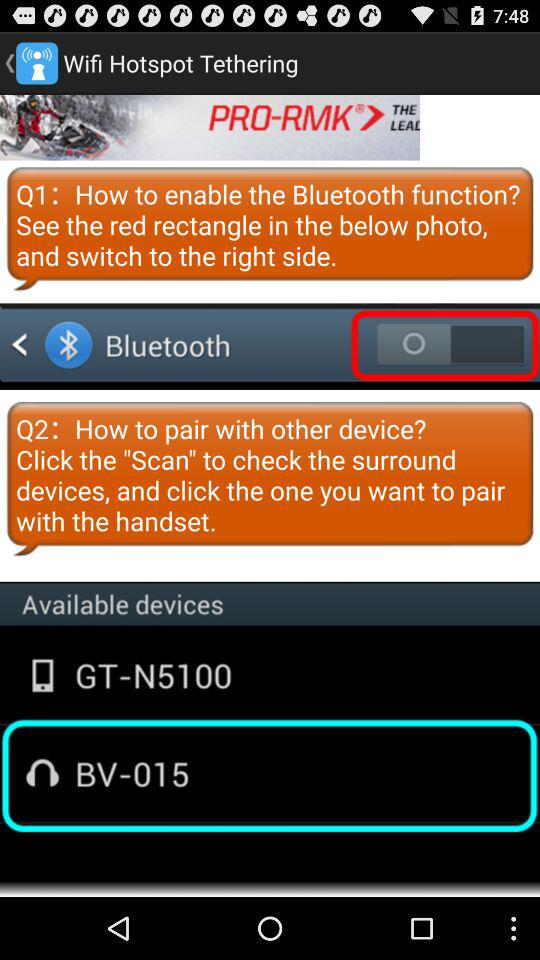What are the available devices? The available devices are "GT - N5100" and "BV - 015". 